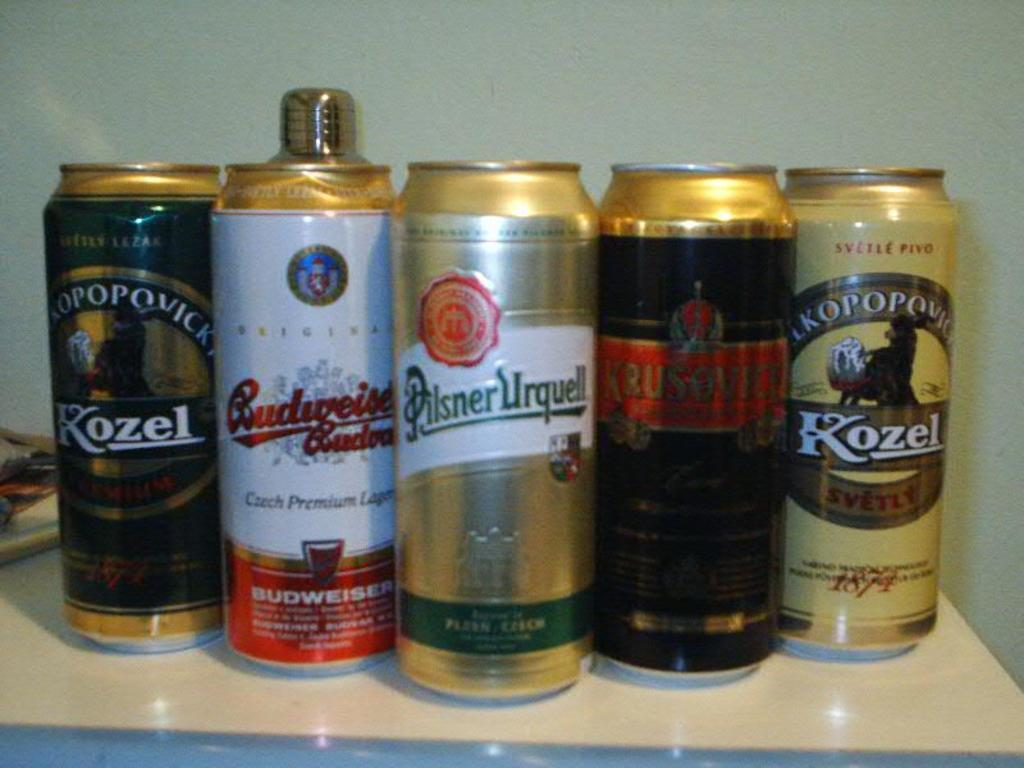Provide a one-sentence caption for the provided image. Two of out the five beers featured are by Kozel. 